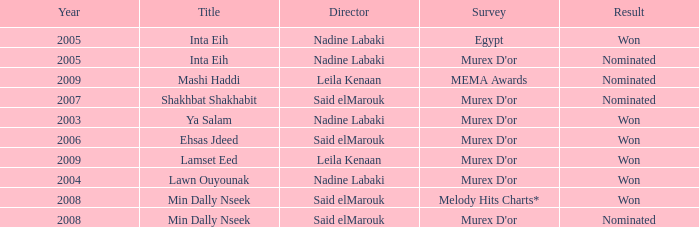What is the title for the Murex D'or survey, after 2005, Said Elmarouk as director, and was nominated? Shakhbat Shakhabit, Min Dally Nseek. 